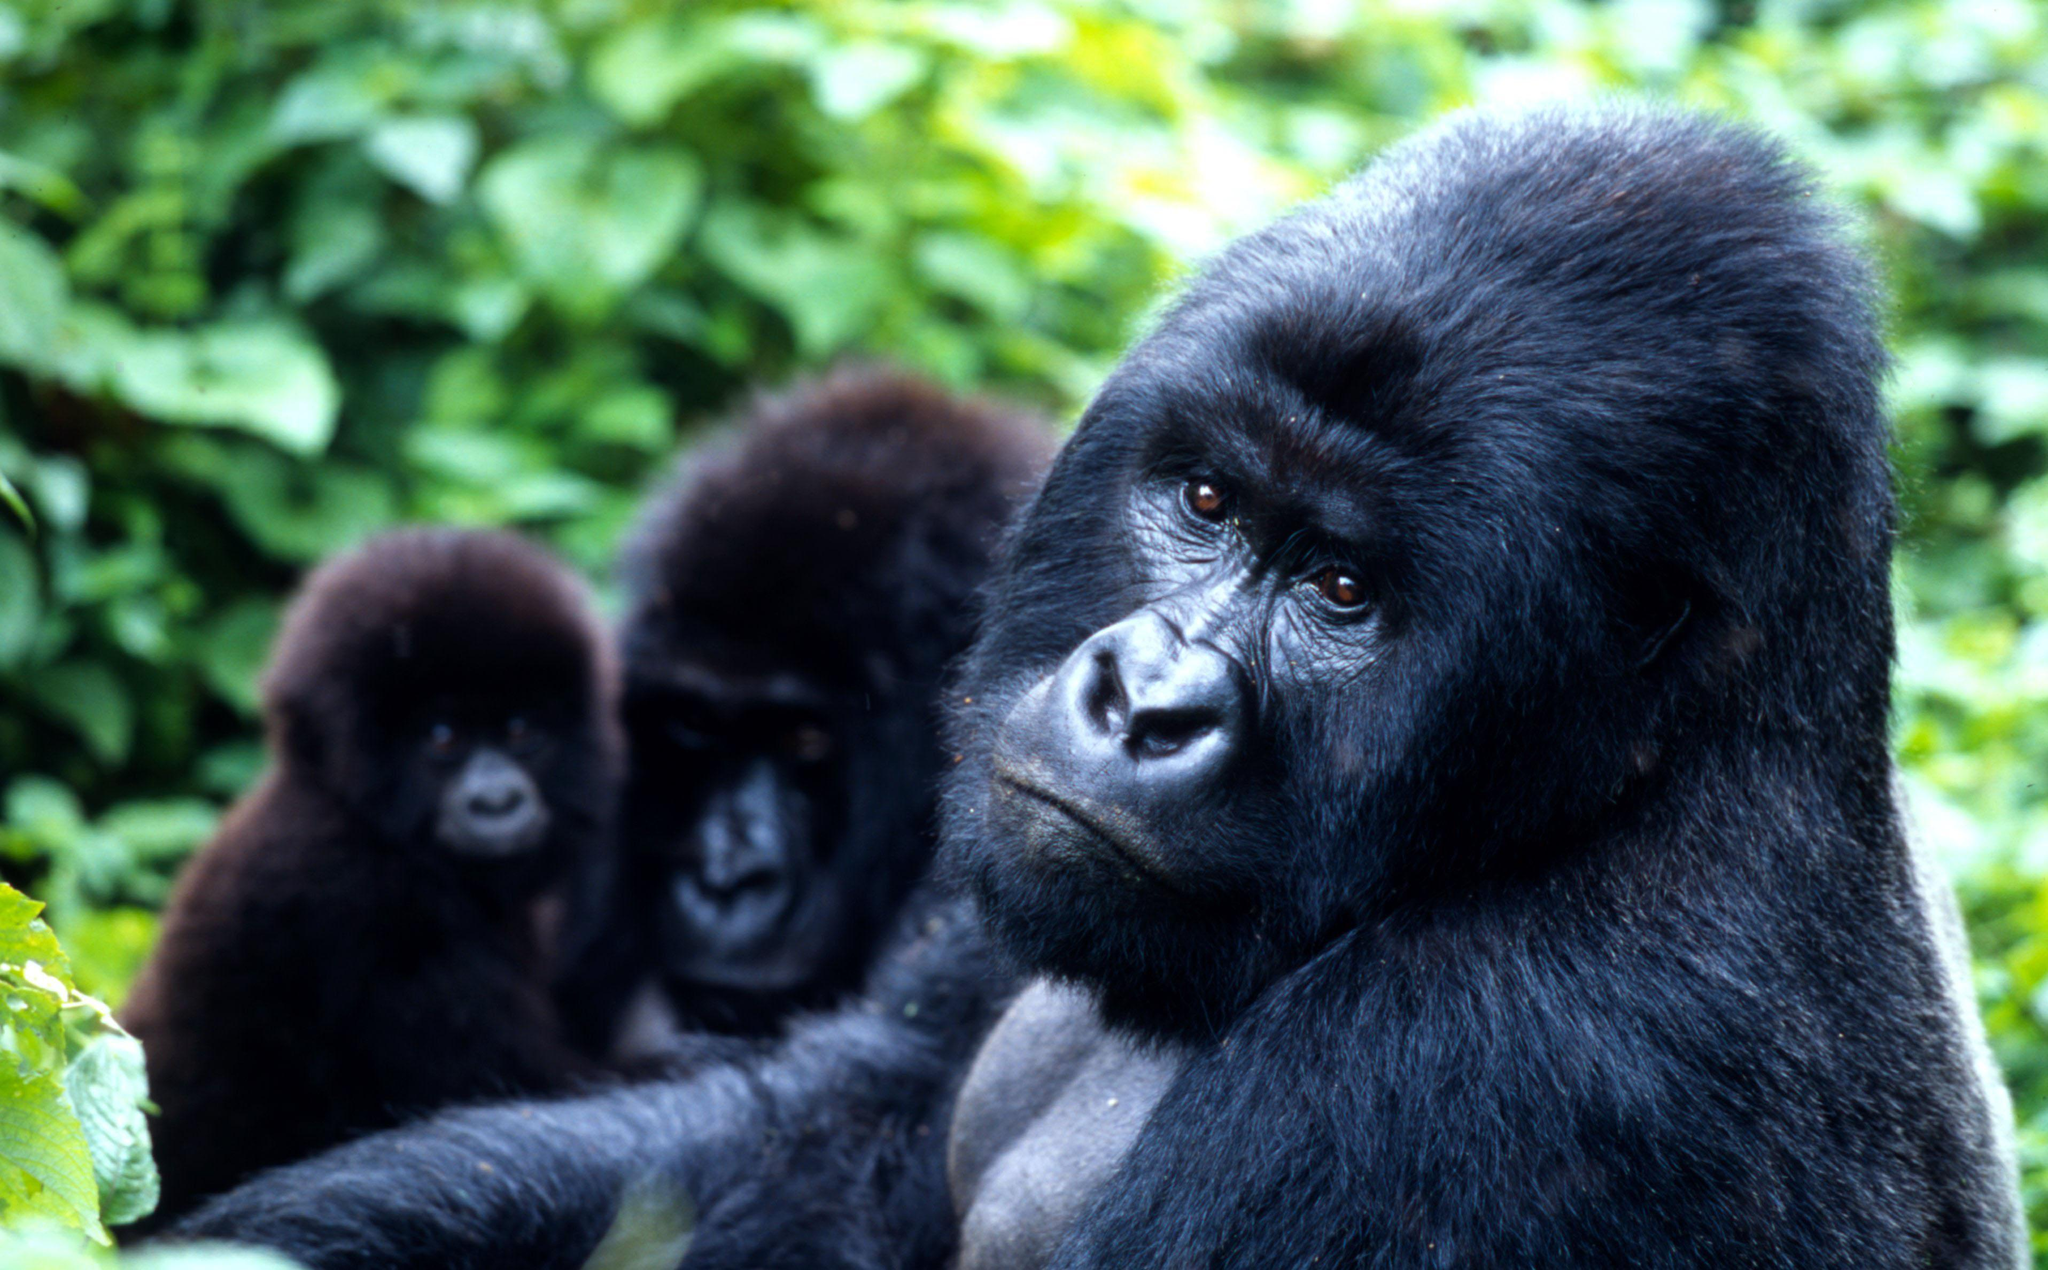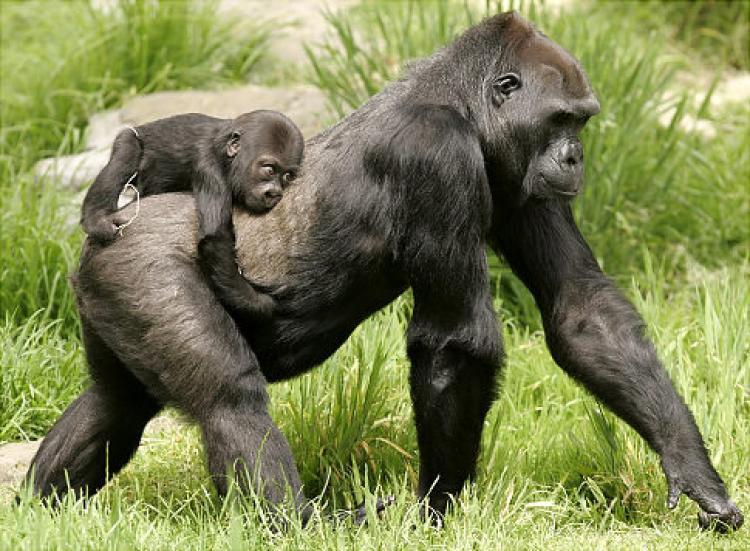The first image is the image on the left, the second image is the image on the right. Examine the images to the left and right. Is the description "Right image shows exactly two apes, a baby grasping an adult." accurate? Answer yes or no. Yes. The first image is the image on the left, the second image is the image on the right. Considering the images on both sides, is "There are a total of 5 gorillas with one being a baby being elevated off of the ground by an adult gorilla." valid? Answer yes or no. Yes. 